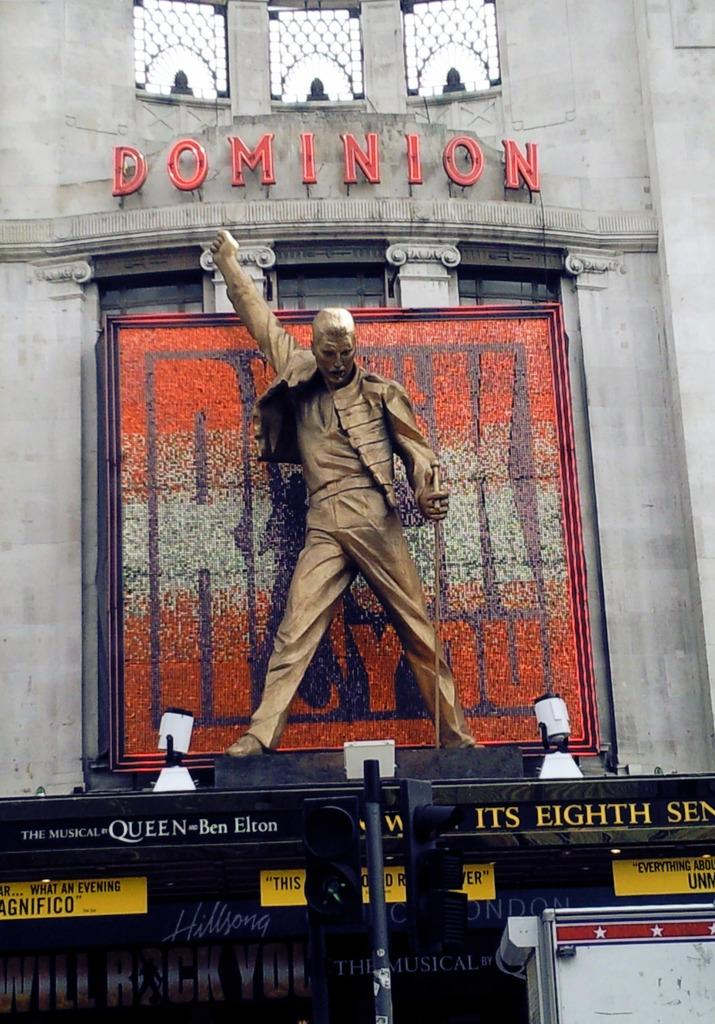<image>
Present a compact description of the photo's key features. A statue of a man poses atop the Dominion 